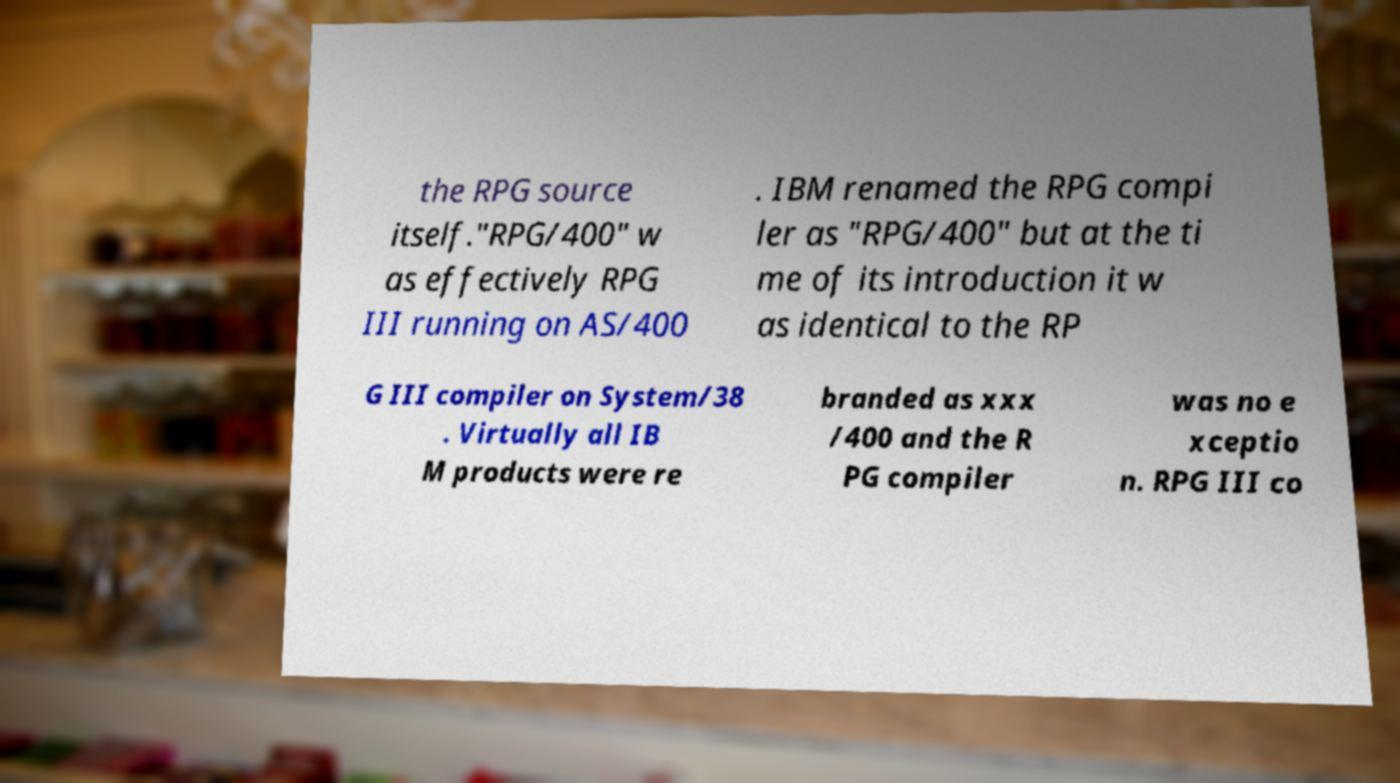Please identify and transcribe the text found in this image. the RPG source itself."RPG/400" w as effectively RPG III running on AS/400 . IBM renamed the RPG compi ler as "RPG/400" but at the ti me of its introduction it w as identical to the RP G III compiler on System/38 . Virtually all IB M products were re branded as xxx /400 and the R PG compiler was no e xceptio n. RPG III co 